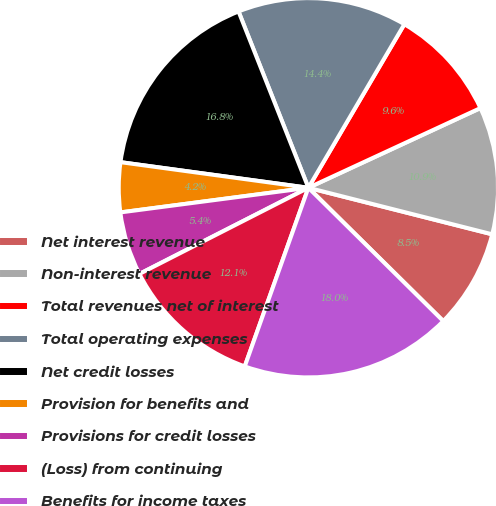Convert chart to OTSL. <chart><loc_0><loc_0><loc_500><loc_500><pie_chart><fcel>Net interest revenue<fcel>Non-interest revenue<fcel>Total revenues net of interest<fcel>Total operating expenses<fcel>Net credit losses<fcel>Provision for benefits and<fcel>Provisions for credit losses<fcel>(Loss) from continuing<fcel>Benefits for income taxes<nl><fcel>8.46%<fcel>10.85%<fcel>9.65%<fcel>14.45%<fcel>16.84%<fcel>4.23%<fcel>5.43%<fcel>12.05%<fcel>18.04%<nl></chart> 